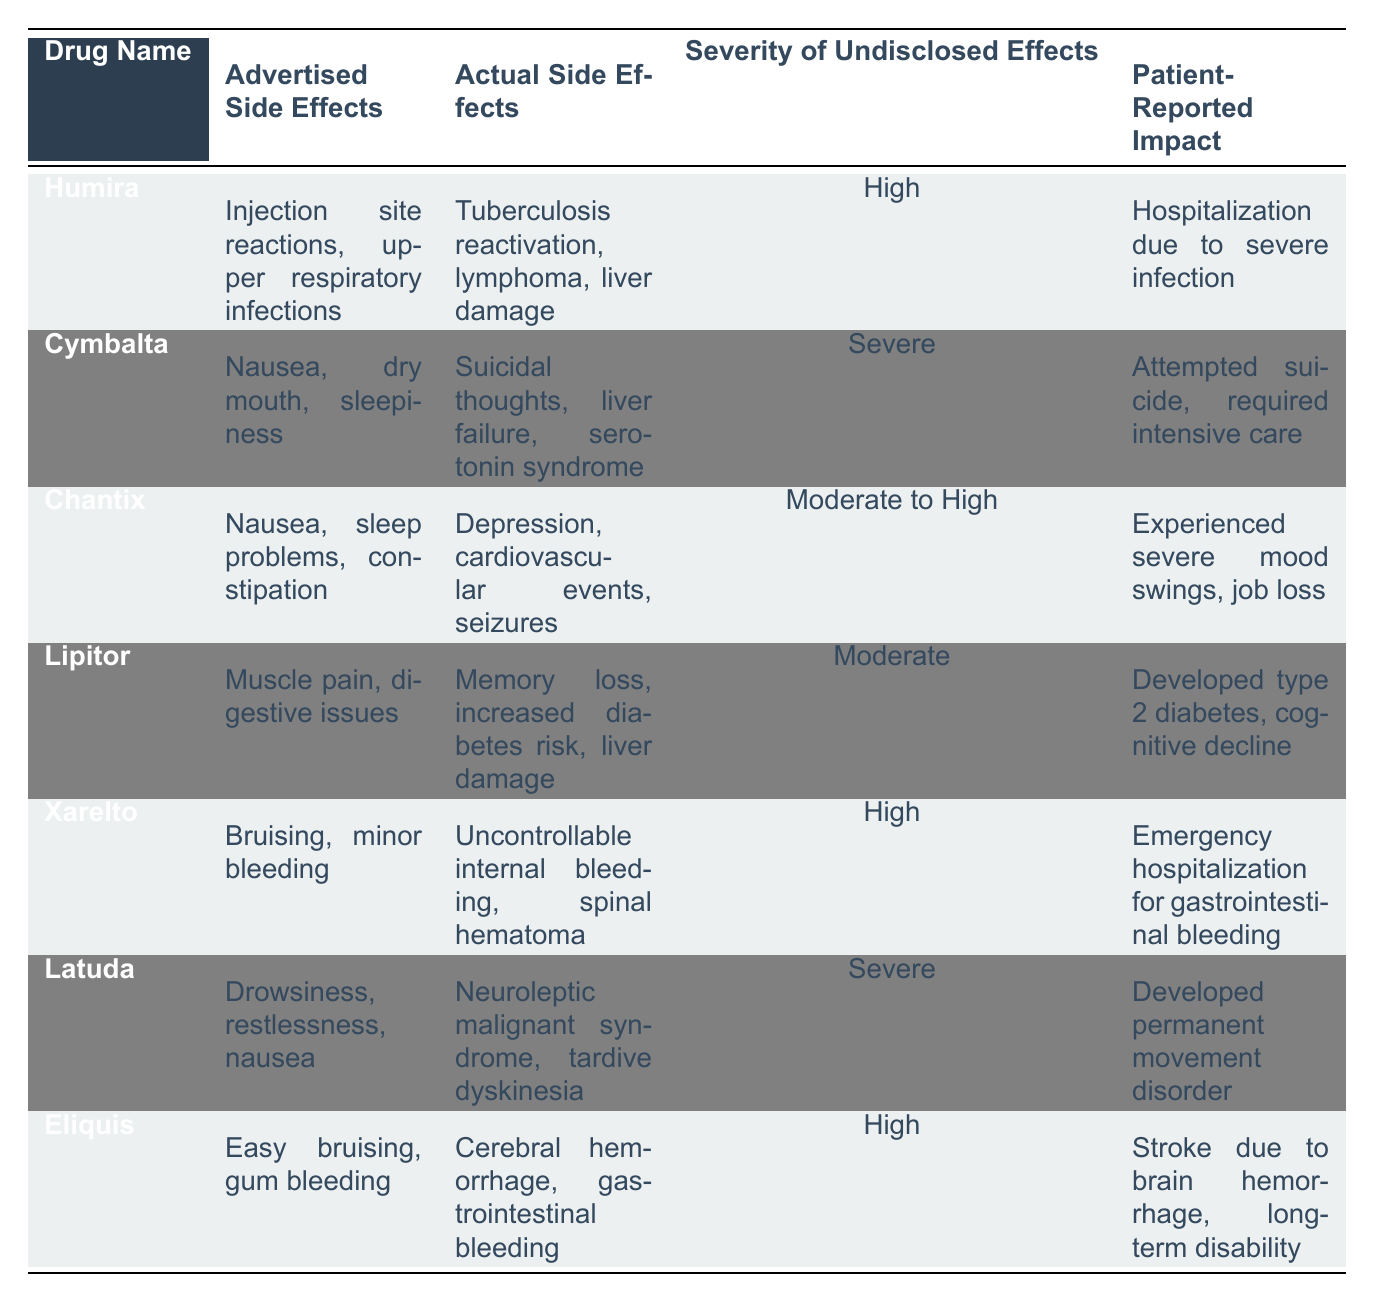What are the advertised side effects of Humira? The table specifies that the advertised side effects of Humira are injection site reactions and upper respiratory infections.
Answer: Injection site reactions, upper respiratory infections What is the severity of undisclosed side effects for Cymbalta? According to the table, the severity of undisclosed effects for Cymbalta is classified as severe.
Answer: Severe Which drug has reported patient impacts resulting in hospitalization due to severe infection? The table indicates that Humira is associated with a patient-reported impact leading to hospitalization due to a severe infection.
Answer: Humira Are the actual side effects of Chantix more severe than the advertised side effects? Yes, the actual side effects of Chantix include depression, cardiovascular events, and seizures, which are more serious than the advertised nausea, sleep problems, and constipation.
Answer: Yes Which drug has the highest severity rating for undisclosed side effects? Both Cymbalta and Latuda are rated as severe for undisclosed side effects, but they both represent the highest severity level in the table.
Answer: Cymbalta and Latuda What is the relationship between the advertised and actual side effects of Xarelto? The advertised side effects include bruising and minor bleeding, which are far less serious than the actual side effects of uncontrollable internal bleeding and spinal hematoma.
Answer: The actual side effects are much more serious How many drugs in the table report high severity for undisclosed effects? There are three drugs that report a high severity for undisclosed effects, specifically Humira, Xarelto, and Eliquis.
Answer: Three What is the total number of severe patient-reported impacts listed in the table? The drugs with severe patient-reported impacts are Cymbalta and Latuda, providing a total of two instances.
Answer: Two Which drug's undisclosed side effects include liver damage? The actual side effects of both Humira and Cymbalta mention liver damage, showing significant undisclosed risks.
Answer: Humira and Cymbalta Is there a drug that lists both a moderate and a severe severity rating for undisclosed effects? No, each drug in the table is categorized strictly as high, severe, or moderate to high, without overlap.
Answer: No 